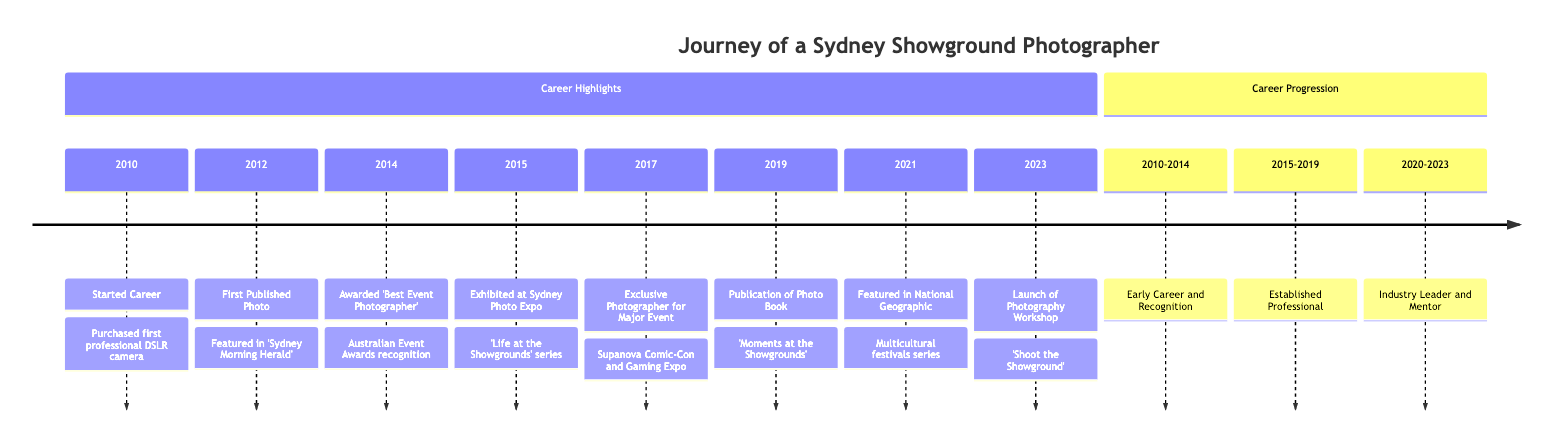What's the first event listed in the timeline? The timeline begins with the event "Started Career" in 2010. This is the earliest entry and marks the beginning of the photographer's journey.
Answer: Started Career In which year was the photographer awarded 'Best Event Photographer'? The event 'Awarded Best Event Photographer' occurred in 2014. This is mentioned explicitly in the timeline, and hence the answer is straightforward.
Answer: 2014 How many years passed between the first published photo and the launch of the photography workshop? The first published photo was in 2012, and the photography workshop was launched in 2023. The difference between these two years is 2023 - 2012 = 11 years.
Answer: 11 years What was the title of the series exhibited at the Sydney Photo Expo? The title of the series showcased at the Sydney Photo Expo in 2015 was 'Life at the Showgrounds.' This specific information is stated in the event details.
Answer: Life at the Showgrounds Which publication featured the photographer's work in 2021? The photographer's work was featured in National Geographic in 2021, as listed in the timeline. This publication is specifically named in the details.
Answer: National Geographic Between which years did the photographer have an early career and recognition? The early career and recognition phase is defined as 2010 to 2014 in the timeline, indicating the duration of early achievements.
Answer: 2010-2014 What significant publication was released in 2019? In 2019, the photographer released a coffee table book titled 'Moments at the Showgrounds.' This title is prominently mentioned in the event details.
Answer: Moments at the Showgrounds Which event was the photographer exclusively contracted for in 2017? In 2017, the photographer was contracted as the exclusive photographer for the Supanova Comic-Con and Gaming Expo. This specific event is highlighted in the timeline.
Answer: Supanova Comic-Con and Gaming Expo 